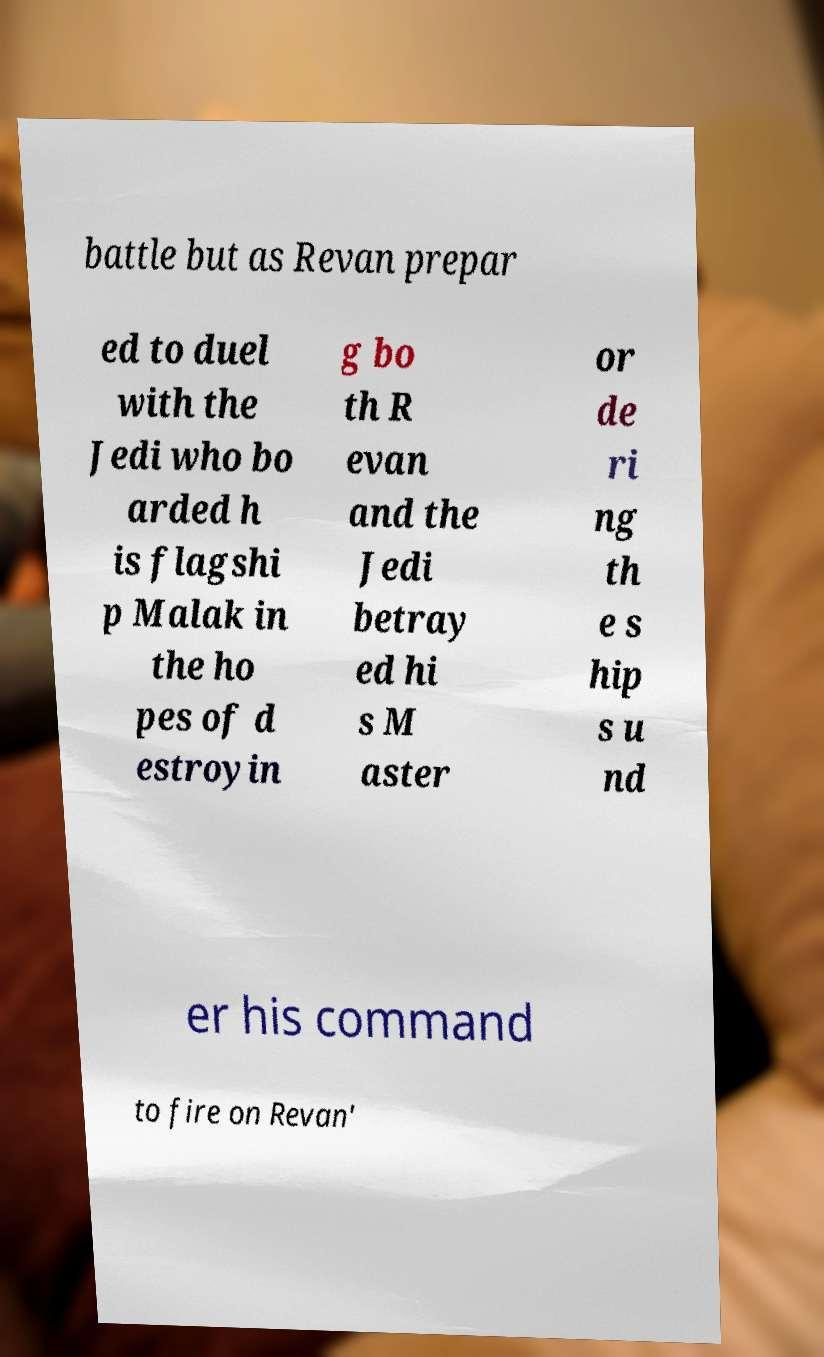I need the written content from this picture converted into text. Can you do that? battle but as Revan prepar ed to duel with the Jedi who bo arded h is flagshi p Malak in the ho pes of d estroyin g bo th R evan and the Jedi betray ed hi s M aster or de ri ng th e s hip s u nd er his command to fire on Revan' 